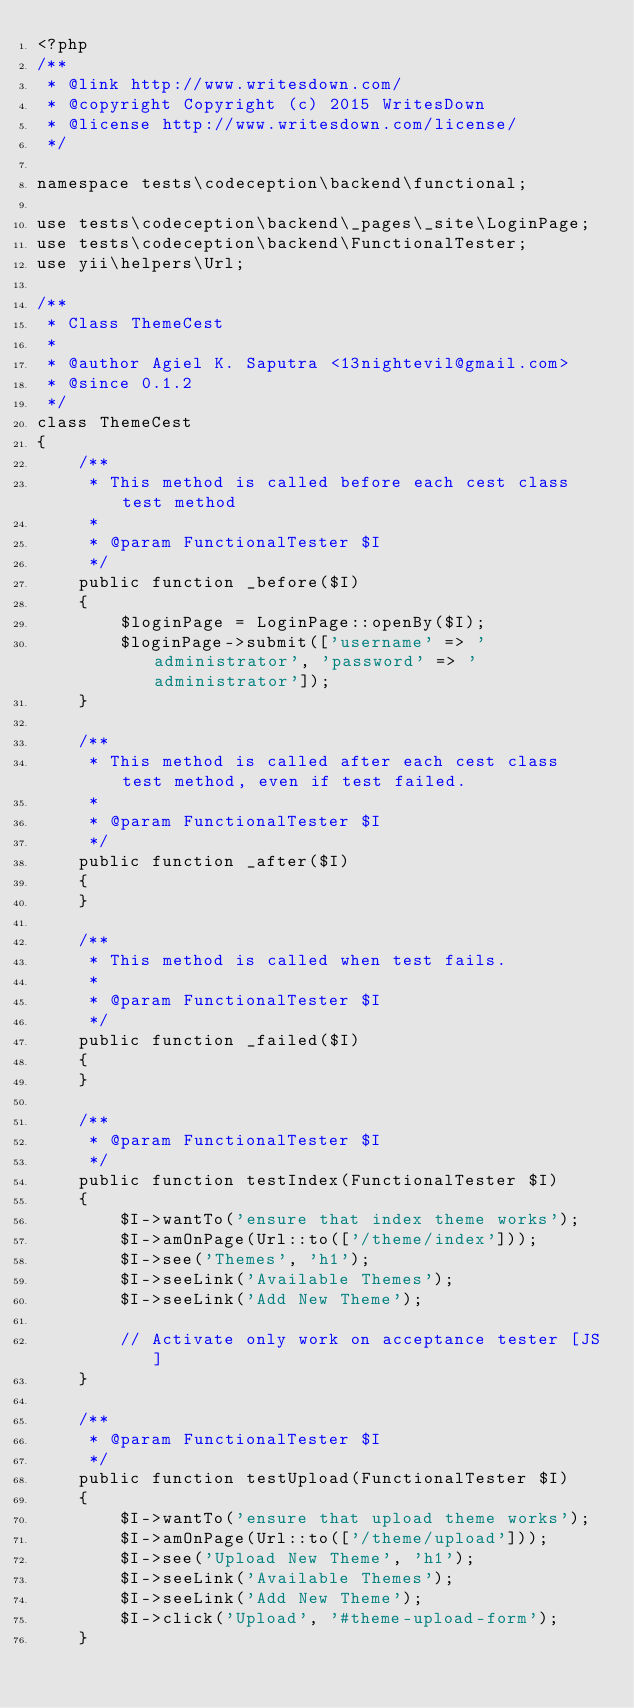<code> <loc_0><loc_0><loc_500><loc_500><_PHP_><?php
/**
 * @link http://www.writesdown.com/
 * @copyright Copyright (c) 2015 WritesDown
 * @license http://www.writesdown.com/license/
 */

namespace tests\codeception\backend\functional;

use tests\codeception\backend\_pages\_site\LoginPage;
use tests\codeception\backend\FunctionalTester;
use yii\helpers\Url;

/**
 * Class ThemeCest
 *
 * @author Agiel K. Saputra <13nightevil@gmail.com>
 * @since 0.1.2
 */
class ThemeCest
{
    /**
     * This method is called before each cest class test method
     *
     * @param FunctionalTester $I
     */
    public function _before($I)
    {
        $loginPage = LoginPage::openBy($I);
        $loginPage->submit(['username' => 'administrator', 'password' => 'administrator']);
    }

    /**
     * This method is called after each cest class test method, even if test failed.
     *
     * @param FunctionalTester $I
     */
    public function _after($I)
    {
    }

    /**
     * This method is called when test fails.
     *
     * @param FunctionalTester $I
     */
    public function _failed($I)
    {
    }

    /**
     * @param FunctionalTester $I
     */
    public function testIndex(FunctionalTester $I)
    {
        $I->wantTo('ensure that index theme works');
        $I->amOnPage(Url::to(['/theme/index']));
        $I->see('Themes', 'h1');
        $I->seeLink('Available Themes');
        $I->seeLink('Add New Theme');

        // Activate only work on acceptance tester [JS]
    }

    /**
     * @param FunctionalTester $I
     */
    public function testUpload(FunctionalTester $I)
    {
        $I->wantTo('ensure that upload theme works');
        $I->amOnPage(Url::to(['/theme/upload']));
        $I->see('Upload New Theme', 'h1');
        $I->seeLink('Available Themes');
        $I->seeLink('Add New Theme');
        $I->click('Upload', '#theme-upload-form');
    }
</code> 